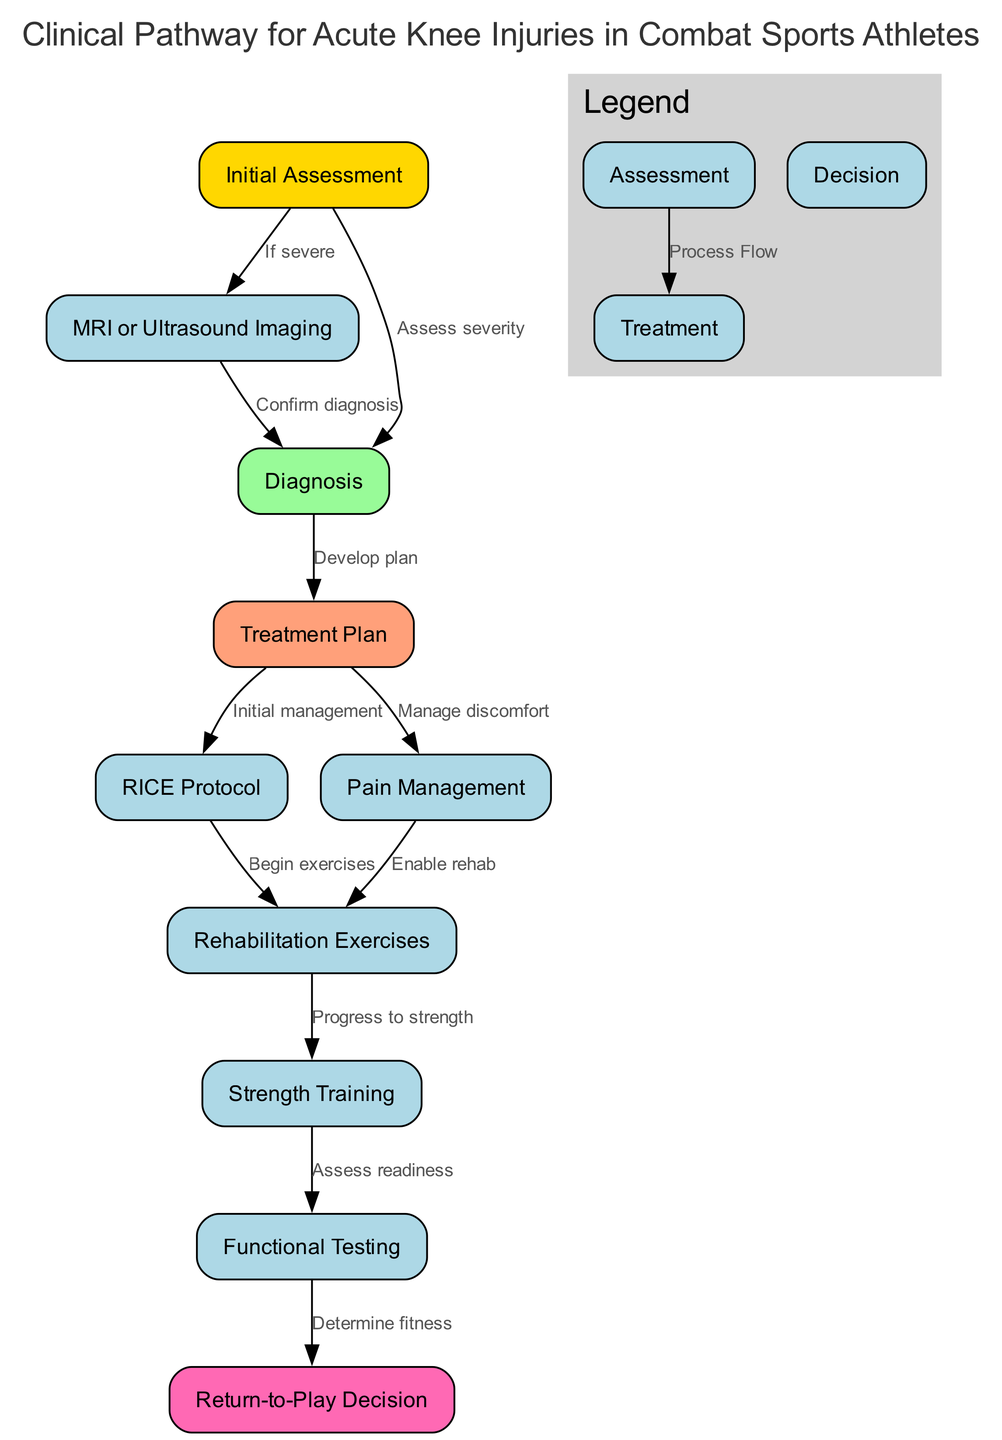What is the first step in the clinical pathway? The diagram shows that the first step is "Initial Assessment," which is the starting point for treating acute knee injuries.
Answer: Initial Assessment How many nodes are present in the clinical pathway? By counting the unique steps or elements in the diagram, there are a total of 10 nodes highlighted that represent the stages from assessment to return-to-play.
Answer: 10 What is the relationship between “Initial Assessment” and “MRI or Ultrasound Imaging”? The edge indicates that "MRI or Ultrasound Imaging" is a subsequent step if the "Initial Assessment" determines that the injury is severe, demonstrating a conditional relationship.
Answer: If severe Which node follows “Diagnosis”? According to the diagram's flow, after reaching the "Diagnosis" node, the next logical step is to develop a "Treatment Plan," demonstrating a sequential progression in the treatment process.
Answer: Treatment Plan What action is taken after “Pain Management”? Once "Pain Management" is achieved, the next step is to "Enable rehab." This indicates that managing pain is a precursor to starting rehabilitation exercises.
Answer: Enable rehab What is the final decision-making point in the clinical pathway? The diagram clearly marks "Return-to-Play Decision" as the last node, which signifies it is the endpoint where the athlete's readiness to return to competition is assessed.
Answer: Return-to-Play Decision What type of exercises start after the implementation of the RICE protocol? Following the "RICE Protocol," it directly indicates that "Rehabilitation Exercises" commence, marking the beginning of active recovery phase post-initial treatment.
Answer: Rehabilitation Exercises Which two nodes directly connect to “Treatment Plan”? The two nodes directly connected to the "Treatment Plan" are "RICE Protocol" for initial management and "Pain Management" for managing discomfort, both of which are essential components of the treatment approach.
Answer: RICE Protocol, Pain Management What step follows “Functional Testing”? Following "Functional Testing," the next step indicated is the "Return-to-Play Decision," demonstrating that fitness assessment is essential before deciding on the athlete’s return to competition.
Answer: Return-to-Play Decision 